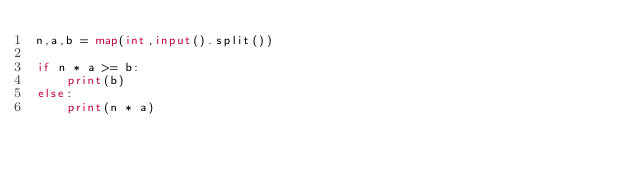<code> <loc_0><loc_0><loc_500><loc_500><_Python_>n,a,b = map(int,input().split())

if n * a >= b:
    print(b)
else:
    print(n * a)
</code> 